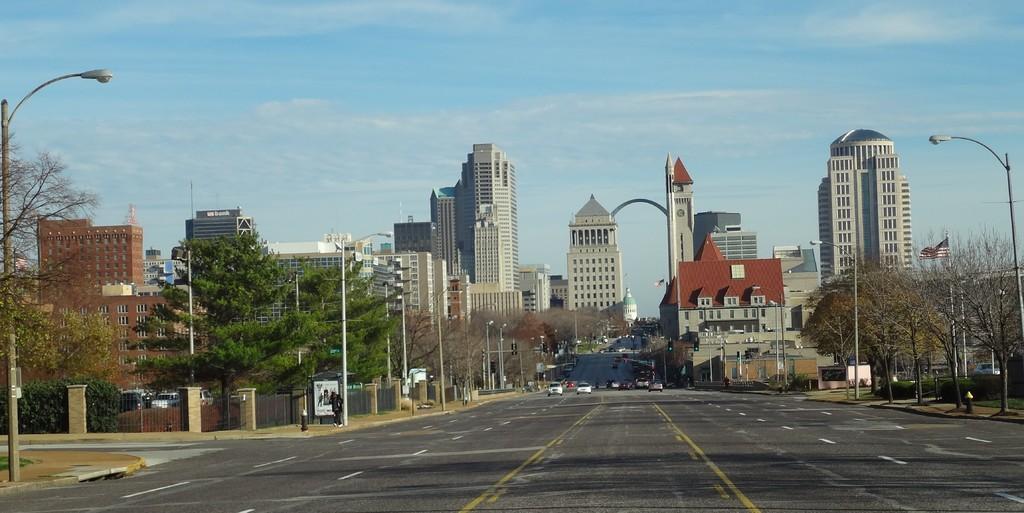Can you describe this image briefly? In the foreground of the picture I can see the cars on the road. I can see the light poles on both sides of the road. There are trees on the left side and the right side as well. In the background, I can see the tower buildings. There are clouds in the sky. 